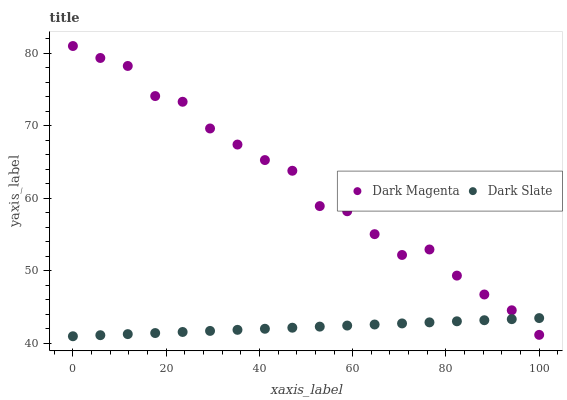Does Dark Slate have the minimum area under the curve?
Answer yes or no. Yes. Does Dark Magenta have the maximum area under the curve?
Answer yes or no. Yes. Does Dark Magenta have the minimum area under the curve?
Answer yes or no. No. Is Dark Slate the smoothest?
Answer yes or no. Yes. Is Dark Magenta the roughest?
Answer yes or no. Yes. Is Dark Magenta the smoothest?
Answer yes or no. No. Does Dark Slate have the lowest value?
Answer yes or no. Yes. Does Dark Magenta have the lowest value?
Answer yes or no. No. Does Dark Magenta have the highest value?
Answer yes or no. Yes. Does Dark Slate intersect Dark Magenta?
Answer yes or no. Yes. Is Dark Slate less than Dark Magenta?
Answer yes or no. No. Is Dark Slate greater than Dark Magenta?
Answer yes or no. No. 